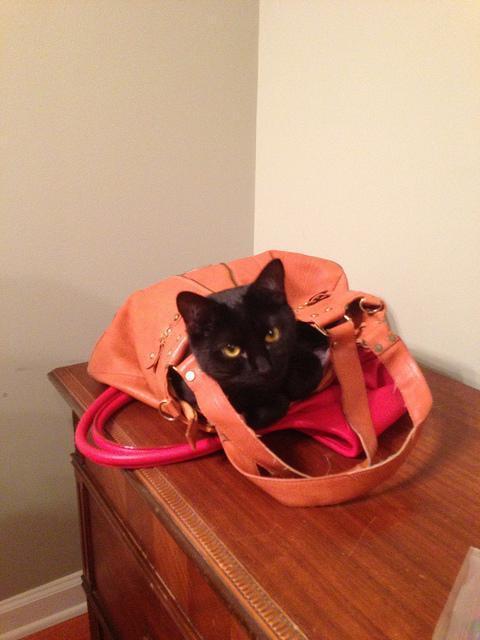How many handbags?
Give a very brief answer. 2. 